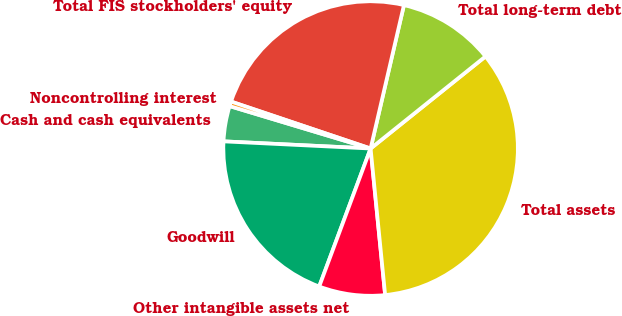Convert chart. <chart><loc_0><loc_0><loc_500><loc_500><pie_chart><fcel>Cash and cash equivalents<fcel>Goodwill<fcel>Other intangible assets net<fcel>Total assets<fcel>Total long-term debt<fcel>Total FIS stockholders' equity<fcel>Noncontrolling interest<nl><fcel>3.88%<fcel>20.1%<fcel>7.25%<fcel>34.18%<fcel>10.61%<fcel>23.47%<fcel>0.51%<nl></chart> 